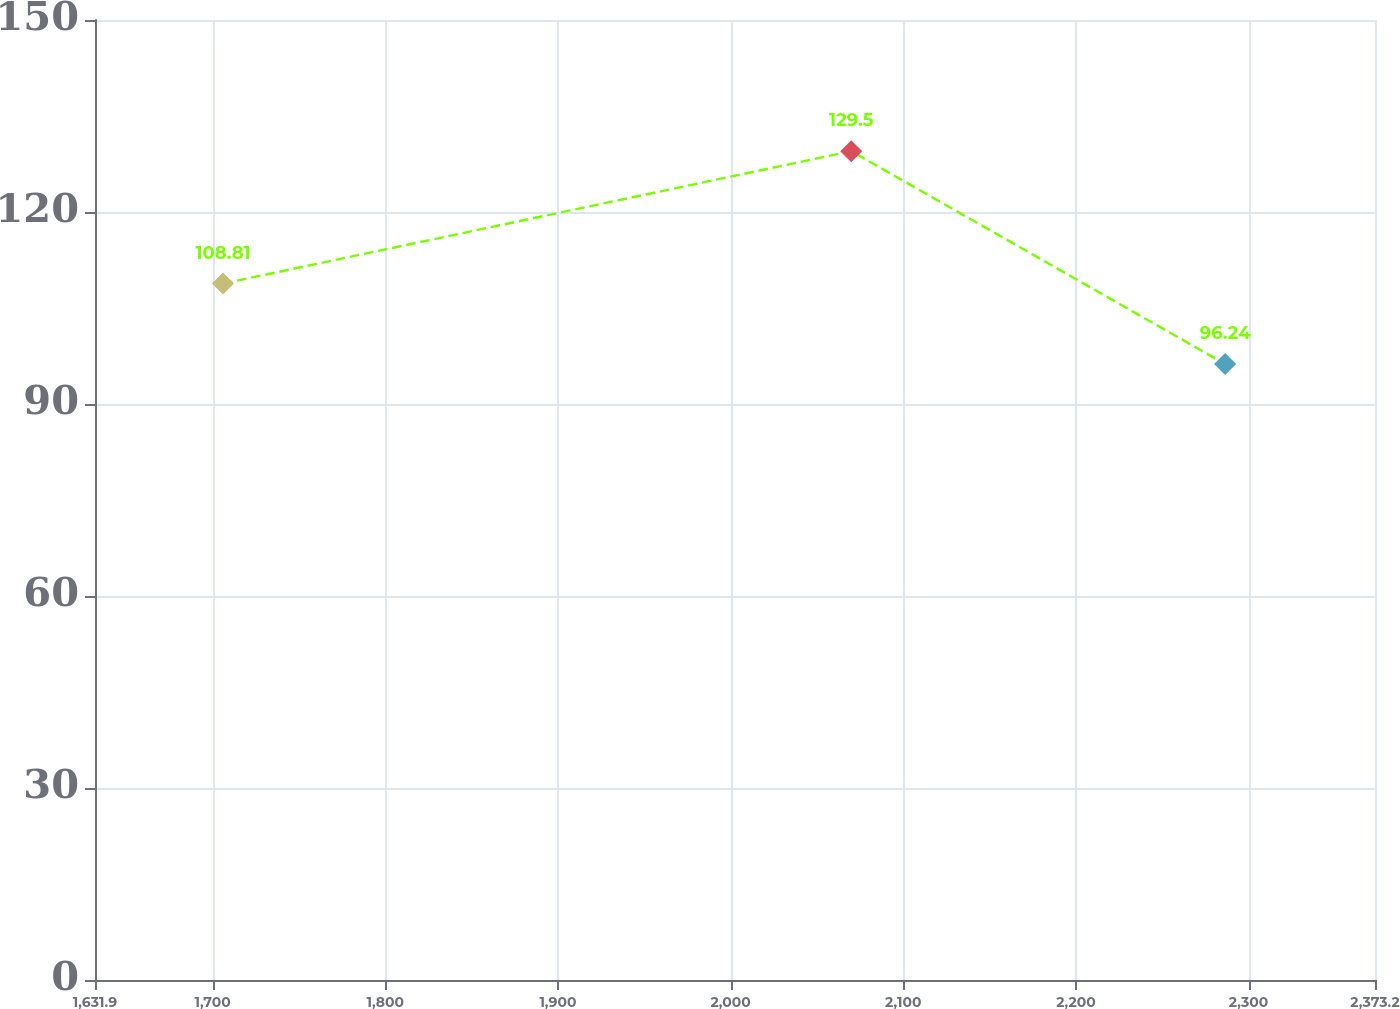Convert chart to OTSL. <chart><loc_0><loc_0><loc_500><loc_500><line_chart><ecel><fcel>Amount<nl><fcel>1706.03<fcel>108.81<nl><fcel>2069.87<fcel>129.5<nl><fcel>2286.41<fcel>96.24<nl><fcel>2376.79<fcel>119.17<nl><fcel>2447.33<fcel>105.48<nl></chart> 